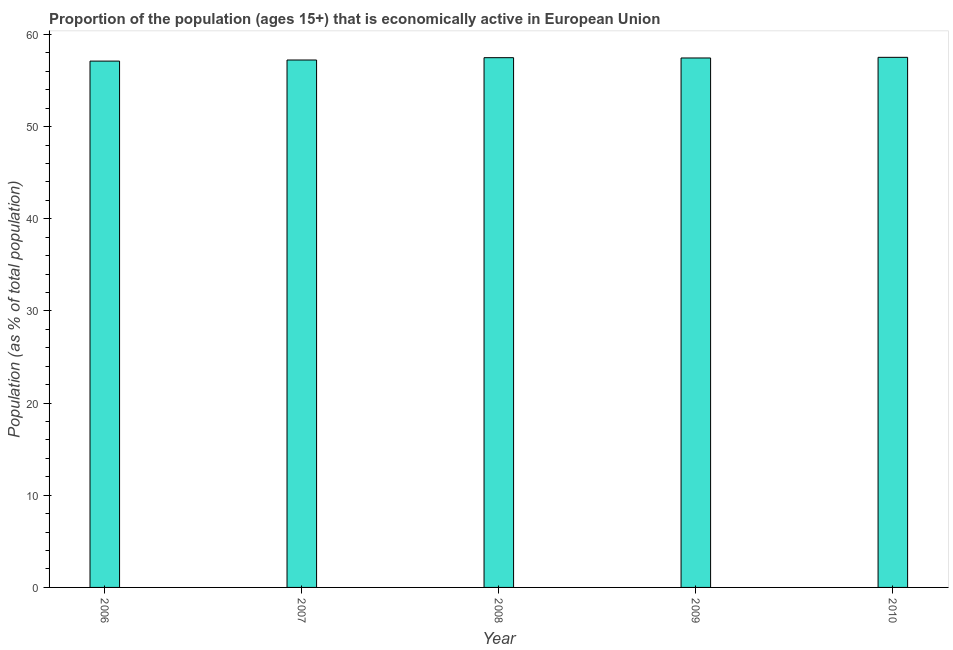Does the graph contain any zero values?
Ensure brevity in your answer.  No. Does the graph contain grids?
Provide a short and direct response. No. What is the title of the graph?
Offer a terse response. Proportion of the population (ages 15+) that is economically active in European Union. What is the label or title of the Y-axis?
Your response must be concise. Population (as % of total population). What is the percentage of economically active population in 2006?
Make the answer very short. 57.11. Across all years, what is the maximum percentage of economically active population?
Provide a succinct answer. 57.51. Across all years, what is the minimum percentage of economically active population?
Offer a very short reply. 57.11. In which year was the percentage of economically active population minimum?
Your answer should be compact. 2006. What is the sum of the percentage of economically active population?
Make the answer very short. 286.77. What is the difference between the percentage of economically active population in 2006 and 2009?
Provide a short and direct response. -0.34. What is the average percentage of economically active population per year?
Your answer should be compact. 57.35. What is the median percentage of economically active population?
Your answer should be very brief. 57.45. In how many years, is the percentage of economically active population greater than 54 %?
Your response must be concise. 5. Do a majority of the years between 2008 and 2006 (inclusive) have percentage of economically active population greater than 56 %?
Keep it short and to the point. Yes. What is the ratio of the percentage of economically active population in 2006 to that in 2009?
Your answer should be very brief. 0.99. What is the difference between the highest and the second highest percentage of economically active population?
Provide a succinct answer. 0.04. What is the difference between the highest and the lowest percentage of economically active population?
Provide a short and direct response. 0.41. In how many years, is the percentage of economically active population greater than the average percentage of economically active population taken over all years?
Ensure brevity in your answer.  3. Are all the bars in the graph horizontal?
Your response must be concise. No. How many years are there in the graph?
Offer a very short reply. 5. What is the difference between two consecutive major ticks on the Y-axis?
Offer a very short reply. 10. What is the Population (as % of total population) in 2006?
Ensure brevity in your answer.  57.11. What is the Population (as % of total population) in 2007?
Keep it short and to the point. 57.22. What is the Population (as % of total population) of 2008?
Keep it short and to the point. 57.48. What is the Population (as % of total population) of 2009?
Give a very brief answer. 57.45. What is the Population (as % of total population) of 2010?
Provide a succinct answer. 57.51. What is the difference between the Population (as % of total population) in 2006 and 2007?
Give a very brief answer. -0.12. What is the difference between the Population (as % of total population) in 2006 and 2008?
Give a very brief answer. -0.37. What is the difference between the Population (as % of total population) in 2006 and 2009?
Your response must be concise. -0.34. What is the difference between the Population (as % of total population) in 2006 and 2010?
Offer a very short reply. -0.41. What is the difference between the Population (as % of total population) in 2007 and 2008?
Ensure brevity in your answer.  -0.25. What is the difference between the Population (as % of total population) in 2007 and 2009?
Offer a terse response. -0.22. What is the difference between the Population (as % of total population) in 2007 and 2010?
Your answer should be very brief. -0.29. What is the difference between the Population (as % of total population) in 2008 and 2009?
Make the answer very short. 0.03. What is the difference between the Population (as % of total population) in 2008 and 2010?
Provide a succinct answer. -0.04. What is the difference between the Population (as % of total population) in 2009 and 2010?
Make the answer very short. -0.07. What is the ratio of the Population (as % of total population) in 2006 to that in 2008?
Your response must be concise. 0.99. What is the ratio of the Population (as % of total population) in 2006 to that in 2009?
Provide a succinct answer. 0.99. What is the ratio of the Population (as % of total population) in 2006 to that in 2010?
Keep it short and to the point. 0.99. What is the ratio of the Population (as % of total population) in 2007 to that in 2009?
Your response must be concise. 1. What is the ratio of the Population (as % of total population) in 2008 to that in 2010?
Provide a succinct answer. 1. 